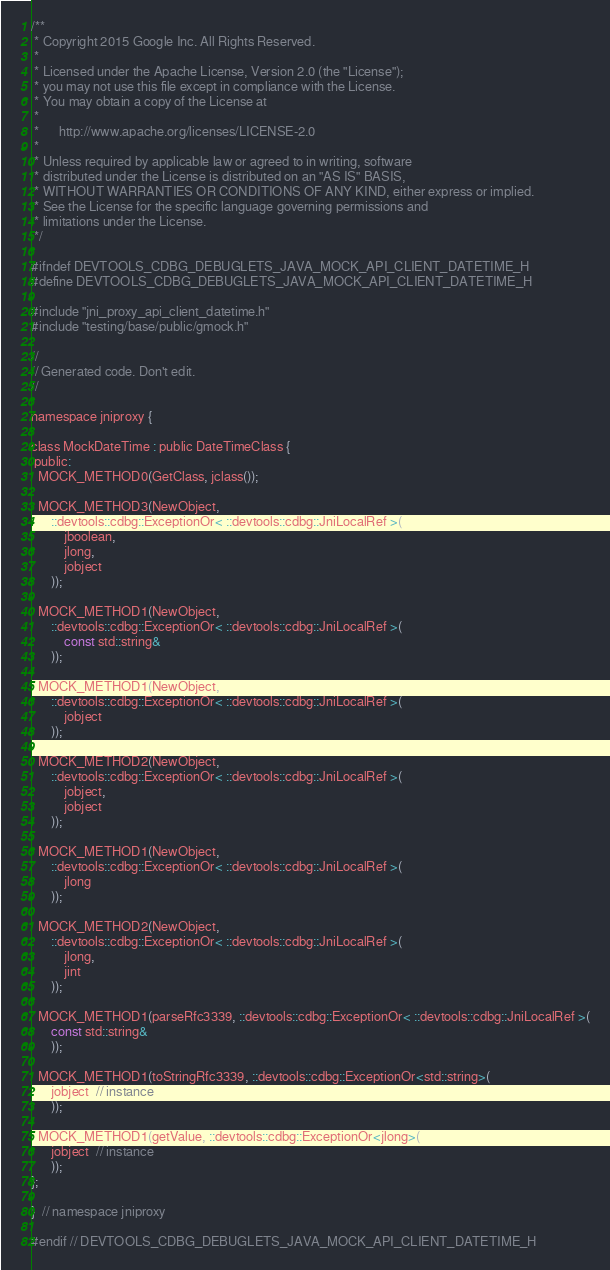<code> <loc_0><loc_0><loc_500><loc_500><_C_>/**
 * Copyright 2015 Google Inc. All Rights Reserved.
 *
 * Licensed under the Apache License, Version 2.0 (the "License");
 * you may not use this file except in compliance with the License.
 * You may obtain a copy of the License at
 *
 *      http://www.apache.org/licenses/LICENSE-2.0
 *
 * Unless required by applicable law or agreed to in writing, software
 * distributed under the License is distributed on an "AS IS" BASIS,
 * WITHOUT WARRANTIES OR CONDITIONS OF ANY KIND, either express or implied.
 * See the License for the specific language governing permissions and
 * limitations under the License.
 */

#ifndef DEVTOOLS_CDBG_DEBUGLETS_JAVA_MOCK_API_CLIENT_DATETIME_H
#define DEVTOOLS_CDBG_DEBUGLETS_JAVA_MOCK_API_CLIENT_DATETIME_H

#include "jni_proxy_api_client_datetime.h"
#include "testing/base/public/gmock.h"

//
// Generated code. Don't edit.
//

namespace jniproxy {

class MockDateTime : public DateTimeClass {
 public:
  MOCK_METHOD0(GetClass, jclass());

  MOCK_METHOD3(NewObject,
      ::devtools::cdbg::ExceptionOr< ::devtools::cdbg::JniLocalRef >(
          jboolean,
          jlong,
          jobject
      ));

  MOCK_METHOD1(NewObject,
      ::devtools::cdbg::ExceptionOr< ::devtools::cdbg::JniLocalRef >(
          const std::string&
      ));

  MOCK_METHOD1(NewObject,
      ::devtools::cdbg::ExceptionOr< ::devtools::cdbg::JniLocalRef >(
          jobject
      ));

  MOCK_METHOD2(NewObject,
      ::devtools::cdbg::ExceptionOr< ::devtools::cdbg::JniLocalRef >(
          jobject,
          jobject
      ));

  MOCK_METHOD1(NewObject,
      ::devtools::cdbg::ExceptionOr< ::devtools::cdbg::JniLocalRef >(
          jlong
      ));

  MOCK_METHOD2(NewObject,
      ::devtools::cdbg::ExceptionOr< ::devtools::cdbg::JniLocalRef >(
          jlong,
          jint
      ));

  MOCK_METHOD1(parseRfc3339, ::devtools::cdbg::ExceptionOr< ::devtools::cdbg::JniLocalRef >(
      const std::string&
      ));

  MOCK_METHOD1(toStringRfc3339, ::devtools::cdbg::ExceptionOr<std::string>(
      jobject  // instance
      ));

  MOCK_METHOD1(getValue, ::devtools::cdbg::ExceptionOr<jlong>(
      jobject  // instance
      ));
};

}  // namespace jniproxy

#endif // DEVTOOLS_CDBG_DEBUGLETS_JAVA_MOCK_API_CLIENT_DATETIME_H
</code> 